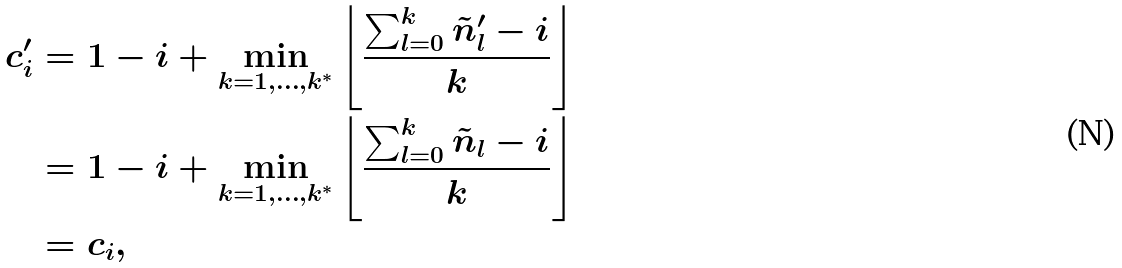Convert formula to latex. <formula><loc_0><loc_0><loc_500><loc_500>c ^ { \prime } _ { i } & = 1 - i + \min _ { k = 1 , \dots , k ^ { * } } \left \lfloor \frac { \sum _ { l = 0 } ^ { k } \tilde { n } ^ { \prime } _ { l } - i } { k } \right \rfloor \\ & = 1 - i + \min _ { k = 1 , \dots , k ^ { * } } \left \lfloor \frac { \sum _ { l = 0 } ^ { k } \tilde { n } _ { l } - i } { k } \right \rfloor \\ & = c _ { i } ,</formula> 